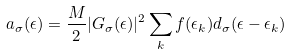<formula> <loc_0><loc_0><loc_500><loc_500>a _ { \sigma } ( \epsilon ) = \frac { M } { 2 } | G _ { \sigma } ( \epsilon ) | ^ { 2 } \sum _ { k } f ( \epsilon _ { k } ) d _ { \sigma } ( \epsilon - \epsilon _ { k } )</formula> 